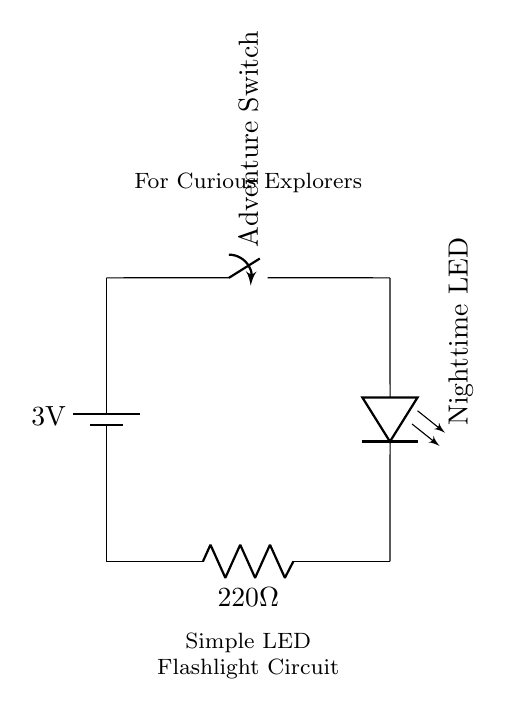What is the type of battery used in this circuit? The battery is labeled as 3V in the circuit diagram, indicating its type and voltage.
Answer: 3V What component acts as a control for the LED? The component that controls the LED is the switch, commonly used to turn the LED on and off.
Answer: Switch What is the value of the resistor in the circuit? The circuit diagram specifically shows a resistor labeled as 220 ohms, which will limit the current through the LED.
Answer: 220 ohm What will happen if the switch is closed? Closing the switch completes the circuit, allowing current to flow and the LED will light up due to the electrical energy.
Answer: LED lights up Why is a resistor used with the LED in this circuit? A resistor is used to limit the current flowing through the LED, preventing it from drawing too much current that can damage it.
Answer: To limit current Which component provides the electrical energy for the circuit? The battery is the source of electrical energy, as indicated by its placement and designation in the circuit diagram.
Answer: Battery What does the label "Nighttime LED" signify in the circuit? "Nighttime LED" indicates that this LED is designed to emit light in the dark, signifying its application in a flashlight context.
Answer: LED 